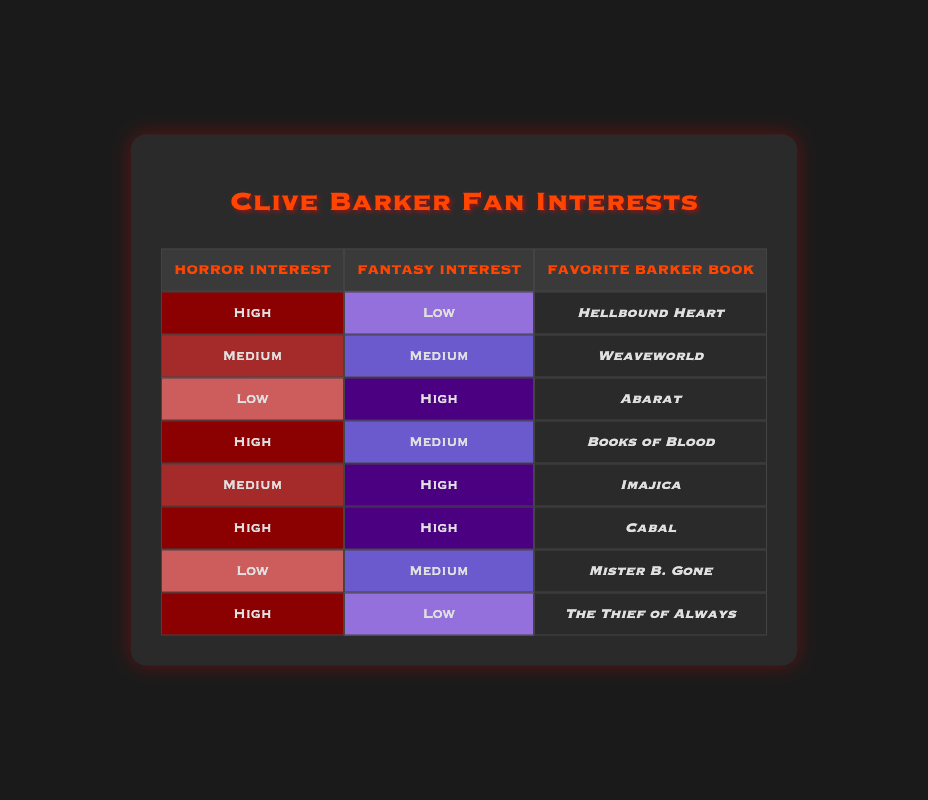What is the favorite Barker book of readers with high horror interest and low fantasy interest? There are two readers in the table with high horror interest and low fantasy interest. They are reader 1 and reader 8. Both of them have different favorite books: reader 1's favorite is "Hellbound Heart" and reader 8's favorite is "The Thief of Always." Therefore, these two books can be identified for this category.
Answer: Hellbound Heart, The Thief of Always How many readers have a medium interest in both horror and fantasy? Looking at the table, we find that there is one reader with medium horror interest and medium fantasy interest, which is reader 2.
Answer: 1 Is there any reader who has low interest in both horror and fantasy? Checking the table, there are no readers with low interest in both horror and fantasy interests. The lowest horror interest recorded is low, and the lowest fantasy interest recorded is low, but no reader has both at this level.
Answer: No What is the total number of readers who have high fantasy interest? From the table, we can see three readers where the fantasy interest is high: readers 3, 5, and 6. By adding them up, we find that there are three readers with high fantasy interest.
Answer: 3 Among readers with high horror interest, which favorite book appears the most? We find that there are four readers with high horror interest: readers 1, 4, 6, and 8. Their favorite books are "Hellbound Heart", "Books of Blood", "Cabal", and "The Thief of Always", respectively. No book appears more than once among these high horror preference readers, so there is no book that appears most often.
Answer: None 